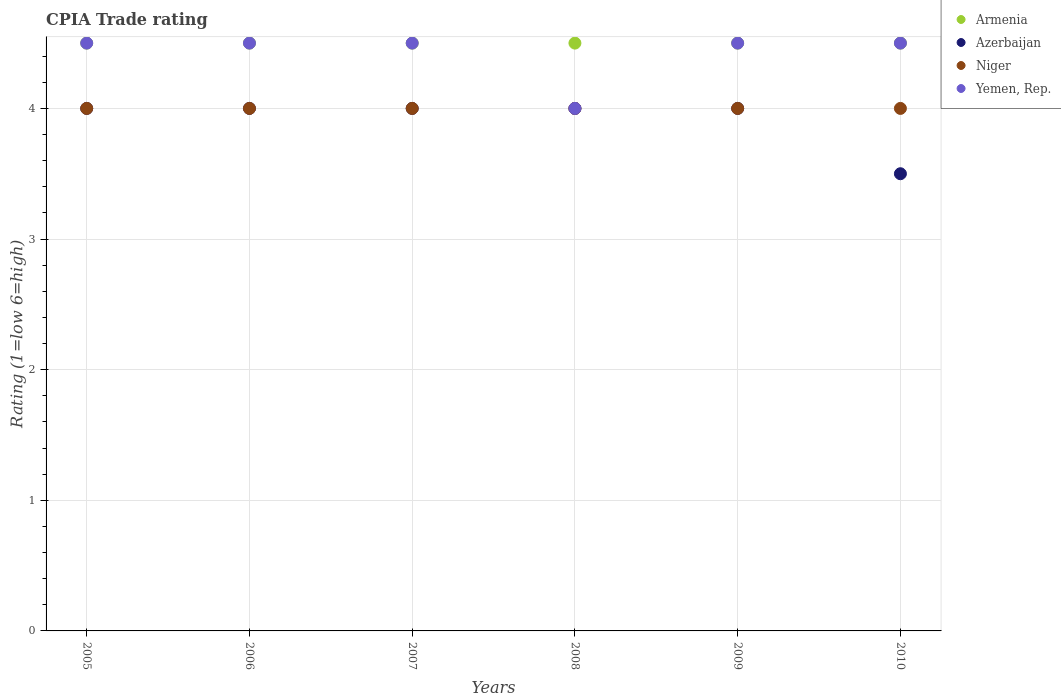What is the CPIA rating in Armenia in 2008?
Your response must be concise. 4.5. In which year was the CPIA rating in Yemen, Rep. maximum?
Provide a short and direct response. 2005. In which year was the CPIA rating in Armenia minimum?
Your answer should be compact. 2005. What is the difference between the CPIA rating in Armenia in 2005 and that in 2008?
Your response must be concise. 0. What is the difference between the CPIA rating in Armenia in 2006 and the CPIA rating in Niger in 2005?
Provide a short and direct response. 0.5. What is the average CPIA rating in Yemen, Rep. per year?
Provide a short and direct response. 4.42. In the year 2009, what is the difference between the CPIA rating in Niger and CPIA rating in Yemen, Rep.?
Your answer should be compact. -0.5. What is the ratio of the CPIA rating in Niger in 2006 to that in 2007?
Ensure brevity in your answer.  1. Is the CPIA rating in Niger in 2005 less than that in 2008?
Your response must be concise. No. Is it the case that in every year, the sum of the CPIA rating in Niger and CPIA rating in Azerbaijan  is greater than the sum of CPIA rating in Yemen, Rep. and CPIA rating in Armenia?
Offer a very short reply. No. Is the CPIA rating in Yemen, Rep. strictly less than the CPIA rating in Niger over the years?
Offer a terse response. No. What is the difference between two consecutive major ticks on the Y-axis?
Keep it short and to the point. 1. Does the graph contain grids?
Keep it short and to the point. Yes. How many legend labels are there?
Your response must be concise. 4. What is the title of the graph?
Keep it short and to the point. CPIA Trade rating. What is the Rating (1=low 6=high) of Armenia in 2005?
Make the answer very short. 4.5. What is the Rating (1=low 6=high) in Yemen, Rep. in 2005?
Offer a very short reply. 4.5. What is the Rating (1=low 6=high) in Yemen, Rep. in 2006?
Provide a succinct answer. 4.5. What is the Rating (1=low 6=high) of Azerbaijan in 2007?
Your response must be concise. 4. What is the Rating (1=low 6=high) of Niger in 2007?
Your answer should be very brief. 4. What is the Rating (1=low 6=high) of Yemen, Rep. in 2007?
Keep it short and to the point. 4.5. What is the Rating (1=low 6=high) in Armenia in 2008?
Give a very brief answer. 4.5. What is the Rating (1=low 6=high) in Azerbaijan in 2008?
Offer a terse response. 4. What is the Rating (1=low 6=high) of Yemen, Rep. in 2008?
Provide a succinct answer. 4. What is the Rating (1=low 6=high) in Armenia in 2009?
Provide a succinct answer. 4.5. What is the Rating (1=low 6=high) of Niger in 2009?
Ensure brevity in your answer.  4. What is the Rating (1=low 6=high) in Yemen, Rep. in 2009?
Ensure brevity in your answer.  4.5. What is the Rating (1=low 6=high) of Niger in 2010?
Ensure brevity in your answer.  4. What is the Rating (1=low 6=high) in Yemen, Rep. in 2010?
Your response must be concise. 4.5. Across all years, what is the minimum Rating (1=low 6=high) in Azerbaijan?
Make the answer very short. 3.5. What is the total Rating (1=low 6=high) in Armenia in the graph?
Give a very brief answer. 27. What is the total Rating (1=low 6=high) in Yemen, Rep. in the graph?
Offer a terse response. 26.5. What is the difference between the Rating (1=low 6=high) of Niger in 2005 and that in 2006?
Provide a short and direct response. 0. What is the difference between the Rating (1=low 6=high) in Armenia in 2005 and that in 2007?
Offer a terse response. 0. What is the difference between the Rating (1=low 6=high) of Niger in 2005 and that in 2007?
Provide a short and direct response. 0. What is the difference between the Rating (1=low 6=high) in Yemen, Rep. in 2005 and that in 2007?
Provide a succinct answer. 0. What is the difference between the Rating (1=low 6=high) in Armenia in 2005 and that in 2008?
Your answer should be very brief. 0. What is the difference between the Rating (1=low 6=high) in Azerbaijan in 2005 and that in 2009?
Offer a terse response. 0. What is the difference between the Rating (1=low 6=high) in Azerbaijan in 2005 and that in 2010?
Ensure brevity in your answer.  0.5. What is the difference between the Rating (1=low 6=high) of Armenia in 2006 and that in 2007?
Ensure brevity in your answer.  0. What is the difference between the Rating (1=low 6=high) in Niger in 2006 and that in 2007?
Your response must be concise. 0. What is the difference between the Rating (1=low 6=high) of Yemen, Rep. in 2006 and that in 2007?
Make the answer very short. 0. What is the difference between the Rating (1=low 6=high) in Azerbaijan in 2006 and that in 2008?
Ensure brevity in your answer.  0. What is the difference between the Rating (1=low 6=high) in Azerbaijan in 2006 and that in 2009?
Your response must be concise. 0. What is the difference between the Rating (1=low 6=high) of Armenia in 2006 and that in 2010?
Provide a succinct answer. 0. What is the difference between the Rating (1=low 6=high) in Azerbaijan in 2006 and that in 2010?
Offer a very short reply. 0.5. What is the difference between the Rating (1=low 6=high) in Yemen, Rep. in 2006 and that in 2010?
Make the answer very short. 0. What is the difference between the Rating (1=low 6=high) in Armenia in 2007 and that in 2009?
Your answer should be very brief. 0. What is the difference between the Rating (1=low 6=high) of Yemen, Rep. in 2007 and that in 2009?
Your answer should be very brief. 0. What is the difference between the Rating (1=low 6=high) of Armenia in 2007 and that in 2010?
Your response must be concise. 0. What is the difference between the Rating (1=low 6=high) in Armenia in 2008 and that in 2009?
Keep it short and to the point. 0. What is the difference between the Rating (1=low 6=high) in Niger in 2008 and that in 2009?
Your answer should be compact. 0. What is the difference between the Rating (1=low 6=high) of Yemen, Rep. in 2008 and that in 2009?
Your answer should be very brief. -0.5. What is the difference between the Rating (1=low 6=high) in Niger in 2008 and that in 2010?
Give a very brief answer. 0. What is the difference between the Rating (1=low 6=high) of Azerbaijan in 2009 and that in 2010?
Offer a very short reply. 0.5. What is the difference between the Rating (1=low 6=high) in Niger in 2009 and that in 2010?
Provide a succinct answer. 0. What is the difference between the Rating (1=low 6=high) in Yemen, Rep. in 2009 and that in 2010?
Provide a succinct answer. 0. What is the difference between the Rating (1=low 6=high) of Armenia in 2005 and the Rating (1=low 6=high) of Yemen, Rep. in 2006?
Your response must be concise. 0. What is the difference between the Rating (1=low 6=high) in Azerbaijan in 2005 and the Rating (1=low 6=high) in Yemen, Rep. in 2006?
Your answer should be compact. -0.5. What is the difference between the Rating (1=low 6=high) in Armenia in 2005 and the Rating (1=low 6=high) in Azerbaijan in 2007?
Keep it short and to the point. 0.5. What is the difference between the Rating (1=low 6=high) in Armenia in 2005 and the Rating (1=low 6=high) in Niger in 2007?
Your answer should be very brief. 0.5. What is the difference between the Rating (1=low 6=high) of Armenia in 2005 and the Rating (1=low 6=high) of Niger in 2008?
Give a very brief answer. 0.5. What is the difference between the Rating (1=low 6=high) of Armenia in 2005 and the Rating (1=low 6=high) of Yemen, Rep. in 2008?
Make the answer very short. 0.5. What is the difference between the Rating (1=low 6=high) in Azerbaijan in 2005 and the Rating (1=low 6=high) in Niger in 2008?
Offer a very short reply. 0. What is the difference between the Rating (1=low 6=high) of Azerbaijan in 2005 and the Rating (1=low 6=high) of Yemen, Rep. in 2008?
Give a very brief answer. 0. What is the difference between the Rating (1=low 6=high) of Niger in 2005 and the Rating (1=low 6=high) of Yemen, Rep. in 2008?
Provide a short and direct response. 0. What is the difference between the Rating (1=low 6=high) of Azerbaijan in 2005 and the Rating (1=low 6=high) of Yemen, Rep. in 2009?
Your response must be concise. -0.5. What is the difference between the Rating (1=low 6=high) of Armenia in 2005 and the Rating (1=low 6=high) of Niger in 2010?
Provide a short and direct response. 0.5. What is the difference between the Rating (1=low 6=high) of Azerbaijan in 2005 and the Rating (1=low 6=high) of Niger in 2010?
Your response must be concise. 0. What is the difference between the Rating (1=low 6=high) in Niger in 2005 and the Rating (1=low 6=high) in Yemen, Rep. in 2010?
Make the answer very short. -0.5. What is the difference between the Rating (1=low 6=high) in Armenia in 2006 and the Rating (1=low 6=high) in Niger in 2007?
Make the answer very short. 0.5. What is the difference between the Rating (1=low 6=high) in Azerbaijan in 2006 and the Rating (1=low 6=high) in Niger in 2007?
Ensure brevity in your answer.  0. What is the difference between the Rating (1=low 6=high) in Niger in 2006 and the Rating (1=low 6=high) in Yemen, Rep. in 2007?
Your answer should be compact. -0.5. What is the difference between the Rating (1=low 6=high) in Armenia in 2006 and the Rating (1=low 6=high) in Azerbaijan in 2008?
Keep it short and to the point. 0.5. What is the difference between the Rating (1=low 6=high) of Armenia in 2006 and the Rating (1=low 6=high) of Niger in 2008?
Offer a very short reply. 0.5. What is the difference between the Rating (1=low 6=high) of Azerbaijan in 2006 and the Rating (1=low 6=high) of Niger in 2008?
Give a very brief answer. 0. What is the difference between the Rating (1=low 6=high) of Niger in 2006 and the Rating (1=low 6=high) of Yemen, Rep. in 2008?
Give a very brief answer. 0. What is the difference between the Rating (1=low 6=high) in Armenia in 2006 and the Rating (1=low 6=high) in Azerbaijan in 2009?
Make the answer very short. 0.5. What is the difference between the Rating (1=low 6=high) in Armenia in 2006 and the Rating (1=low 6=high) in Niger in 2009?
Offer a terse response. 0.5. What is the difference between the Rating (1=low 6=high) of Azerbaijan in 2006 and the Rating (1=low 6=high) of Niger in 2009?
Give a very brief answer. 0. What is the difference between the Rating (1=low 6=high) in Armenia in 2006 and the Rating (1=low 6=high) in Niger in 2010?
Ensure brevity in your answer.  0.5. What is the difference between the Rating (1=low 6=high) of Armenia in 2006 and the Rating (1=low 6=high) of Yemen, Rep. in 2010?
Your answer should be very brief. 0. What is the difference between the Rating (1=low 6=high) of Azerbaijan in 2006 and the Rating (1=low 6=high) of Niger in 2010?
Your answer should be very brief. 0. What is the difference between the Rating (1=low 6=high) in Niger in 2006 and the Rating (1=low 6=high) in Yemen, Rep. in 2010?
Give a very brief answer. -0.5. What is the difference between the Rating (1=low 6=high) in Azerbaijan in 2007 and the Rating (1=low 6=high) in Niger in 2008?
Give a very brief answer. 0. What is the difference between the Rating (1=low 6=high) of Azerbaijan in 2007 and the Rating (1=low 6=high) of Yemen, Rep. in 2008?
Keep it short and to the point. 0. What is the difference between the Rating (1=low 6=high) in Armenia in 2007 and the Rating (1=low 6=high) in Azerbaijan in 2009?
Your response must be concise. 0.5. What is the difference between the Rating (1=low 6=high) of Azerbaijan in 2007 and the Rating (1=low 6=high) of Niger in 2009?
Offer a very short reply. 0. What is the difference between the Rating (1=low 6=high) in Azerbaijan in 2007 and the Rating (1=low 6=high) in Yemen, Rep. in 2009?
Offer a very short reply. -0.5. What is the difference between the Rating (1=low 6=high) in Armenia in 2007 and the Rating (1=low 6=high) in Azerbaijan in 2010?
Provide a short and direct response. 1. What is the difference between the Rating (1=low 6=high) in Niger in 2007 and the Rating (1=low 6=high) in Yemen, Rep. in 2010?
Ensure brevity in your answer.  -0.5. What is the difference between the Rating (1=low 6=high) of Azerbaijan in 2008 and the Rating (1=low 6=high) of Yemen, Rep. in 2009?
Provide a succinct answer. -0.5. What is the difference between the Rating (1=low 6=high) in Niger in 2008 and the Rating (1=low 6=high) in Yemen, Rep. in 2010?
Offer a very short reply. -0.5. What is the difference between the Rating (1=low 6=high) in Azerbaijan in 2009 and the Rating (1=low 6=high) in Niger in 2010?
Offer a very short reply. 0. What is the difference between the Rating (1=low 6=high) of Azerbaijan in 2009 and the Rating (1=low 6=high) of Yemen, Rep. in 2010?
Ensure brevity in your answer.  -0.5. What is the difference between the Rating (1=low 6=high) in Niger in 2009 and the Rating (1=low 6=high) in Yemen, Rep. in 2010?
Offer a very short reply. -0.5. What is the average Rating (1=low 6=high) in Azerbaijan per year?
Make the answer very short. 3.92. What is the average Rating (1=low 6=high) in Niger per year?
Offer a terse response. 4. What is the average Rating (1=low 6=high) in Yemen, Rep. per year?
Give a very brief answer. 4.42. In the year 2005, what is the difference between the Rating (1=low 6=high) in Armenia and Rating (1=low 6=high) in Niger?
Ensure brevity in your answer.  0.5. In the year 2005, what is the difference between the Rating (1=low 6=high) in Armenia and Rating (1=low 6=high) in Yemen, Rep.?
Give a very brief answer. 0. In the year 2005, what is the difference between the Rating (1=low 6=high) of Niger and Rating (1=low 6=high) of Yemen, Rep.?
Your response must be concise. -0.5. In the year 2006, what is the difference between the Rating (1=low 6=high) of Armenia and Rating (1=low 6=high) of Azerbaijan?
Give a very brief answer. 0.5. In the year 2006, what is the difference between the Rating (1=low 6=high) of Armenia and Rating (1=low 6=high) of Niger?
Your answer should be compact. 0.5. In the year 2006, what is the difference between the Rating (1=low 6=high) of Niger and Rating (1=low 6=high) of Yemen, Rep.?
Provide a succinct answer. -0.5. In the year 2007, what is the difference between the Rating (1=low 6=high) of Armenia and Rating (1=low 6=high) of Niger?
Provide a short and direct response. 0.5. In the year 2007, what is the difference between the Rating (1=low 6=high) in Armenia and Rating (1=low 6=high) in Yemen, Rep.?
Keep it short and to the point. 0. In the year 2007, what is the difference between the Rating (1=low 6=high) of Azerbaijan and Rating (1=low 6=high) of Niger?
Provide a succinct answer. 0. In the year 2007, what is the difference between the Rating (1=low 6=high) in Azerbaijan and Rating (1=low 6=high) in Yemen, Rep.?
Ensure brevity in your answer.  -0.5. In the year 2008, what is the difference between the Rating (1=low 6=high) in Armenia and Rating (1=low 6=high) in Yemen, Rep.?
Ensure brevity in your answer.  0.5. In the year 2008, what is the difference between the Rating (1=low 6=high) in Azerbaijan and Rating (1=low 6=high) in Niger?
Your answer should be very brief. 0. In the year 2008, what is the difference between the Rating (1=low 6=high) of Azerbaijan and Rating (1=low 6=high) of Yemen, Rep.?
Offer a very short reply. 0. In the year 2009, what is the difference between the Rating (1=low 6=high) of Armenia and Rating (1=low 6=high) of Niger?
Provide a succinct answer. 0.5. In the year 2009, what is the difference between the Rating (1=low 6=high) of Armenia and Rating (1=low 6=high) of Yemen, Rep.?
Make the answer very short. 0. In the year 2009, what is the difference between the Rating (1=low 6=high) of Azerbaijan and Rating (1=low 6=high) of Yemen, Rep.?
Your response must be concise. -0.5. In the year 2010, what is the difference between the Rating (1=low 6=high) of Armenia and Rating (1=low 6=high) of Niger?
Give a very brief answer. 0.5. What is the ratio of the Rating (1=low 6=high) of Yemen, Rep. in 2005 to that in 2006?
Keep it short and to the point. 1. What is the ratio of the Rating (1=low 6=high) of Azerbaijan in 2005 to that in 2007?
Make the answer very short. 1. What is the ratio of the Rating (1=low 6=high) in Niger in 2005 to that in 2007?
Your response must be concise. 1. What is the ratio of the Rating (1=low 6=high) of Yemen, Rep. in 2005 to that in 2007?
Provide a short and direct response. 1. What is the ratio of the Rating (1=low 6=high) of Armenia in 2005 to that in 2008?
Provide a short and direct response. 1. What is the ratio of the Rating (1=low 6=high) of Niger in 2005 to that in 2008?
Keep it short and to the point. 1. What is the ratio of the Rating (1=low 6=high) of Yemen, Rep. in 2005 to that in 2008?
Your answer should be compact. 1.12. What is the ratio of the Rating (1=low 6=high) in Yemen, Rep. in 2005 to that in 2009?
Offer a very short reply. 1. What is the ratio of the Rating (1=low 6=high) of Niger in 2006 to that in 2007?
Make the answer very short. 1. What is the ratio of the Rating (1=low 6=high) in Yemen, Rep. in 2006 to that in 2007?
Provide a short and direct response. 1. What is the ratio of the Rating (1=low 6=high) of Azerbaijan in 2006 to that in 2008?
Offer a very short reply. 1. What is the ratio of the Rating (1=low 6=high) in Yemen, Rep. in 2006 to that in 2008?
Make the answer very short. 1.12. What is the ratio of the Rating (1=low 6=high) in Armenia in 2006 to that in 2009?
Provide a short and direct response. 1. What is the ratio of the Rating (1=low 6=high) of Yemen, Rep. in 2006 to that in 2009?
Your answer should be compact. 1. What is the ratio of the Rating (1=low 6=high) of Armenia in 2006 to that in 2010?
Your answer should be compact. 1. What is the ratio of the Rating (1=low 6=high) of Armenia in 2007 to that in 2008?
Provide a short and direct response. 1. What is the ratio of the Rating (1=low 6=high) in Niger in 2007 to that in 2008?
Ensure brevity in your answer.  1. What is the ratio of the Rating (1=low 6=high) in Azerbaijan in 2007 to that in 2009?
Your answer should be compact. 1. What is the ratio of the Rating (1=low 6=high) in Yemen, Rep. in 2007 to that in 2009?
Offer a terse response. 1. What is the ratio of the Rating (1=low 6=high) of Armenia in 2007 to that in 2010?
Keep it short and to the point. 1. What is the ratio of the Rating (1=low 6=high) of Niger in 2007 to that in 2010?
Your response must be concise. 1. What is the ratio of the Rating (1=low 6=high) in Armenia in 2008 to that in 2009?
Your answer should be compact. 1. What is the ratio of the Rating (1=low 6=high) of Niger in 2008 to that in 2009?
Offer a very short reply. 1. What is the ratio of the Rating (1=low 6=high) of Armenia in 2008 to that in 2010?
Your answer should be very brief. 1. What is the ratio of the Rating (1=low 6=high) in Azerbaijan in 2008 to that in 2010?
Offer a terse response. 1.14. What is the ratio of the Rating (1=low 6=high) of Niger in 2008 to that in 2010?
Your answer should be compact. 1. What is the ratio of the Rating (1=low 6=high) in Yemen, Rep. in 2008 to that in 2010?
Give a very brief answer. 0.89. What is the difference between the highest and the second highest Rating (1=low 6=high) of Armenia?
Provide a succinct answer. 0. What is the difference between the highest and the second highest Rating (1=low 6=high) in Azerbaijan?
Offer a terse response. 0. What is the difference between the highest and the lowest Rating (1=low 6=high) of Azerbaijan?
Ensure brevity in your answer.  0.5. 